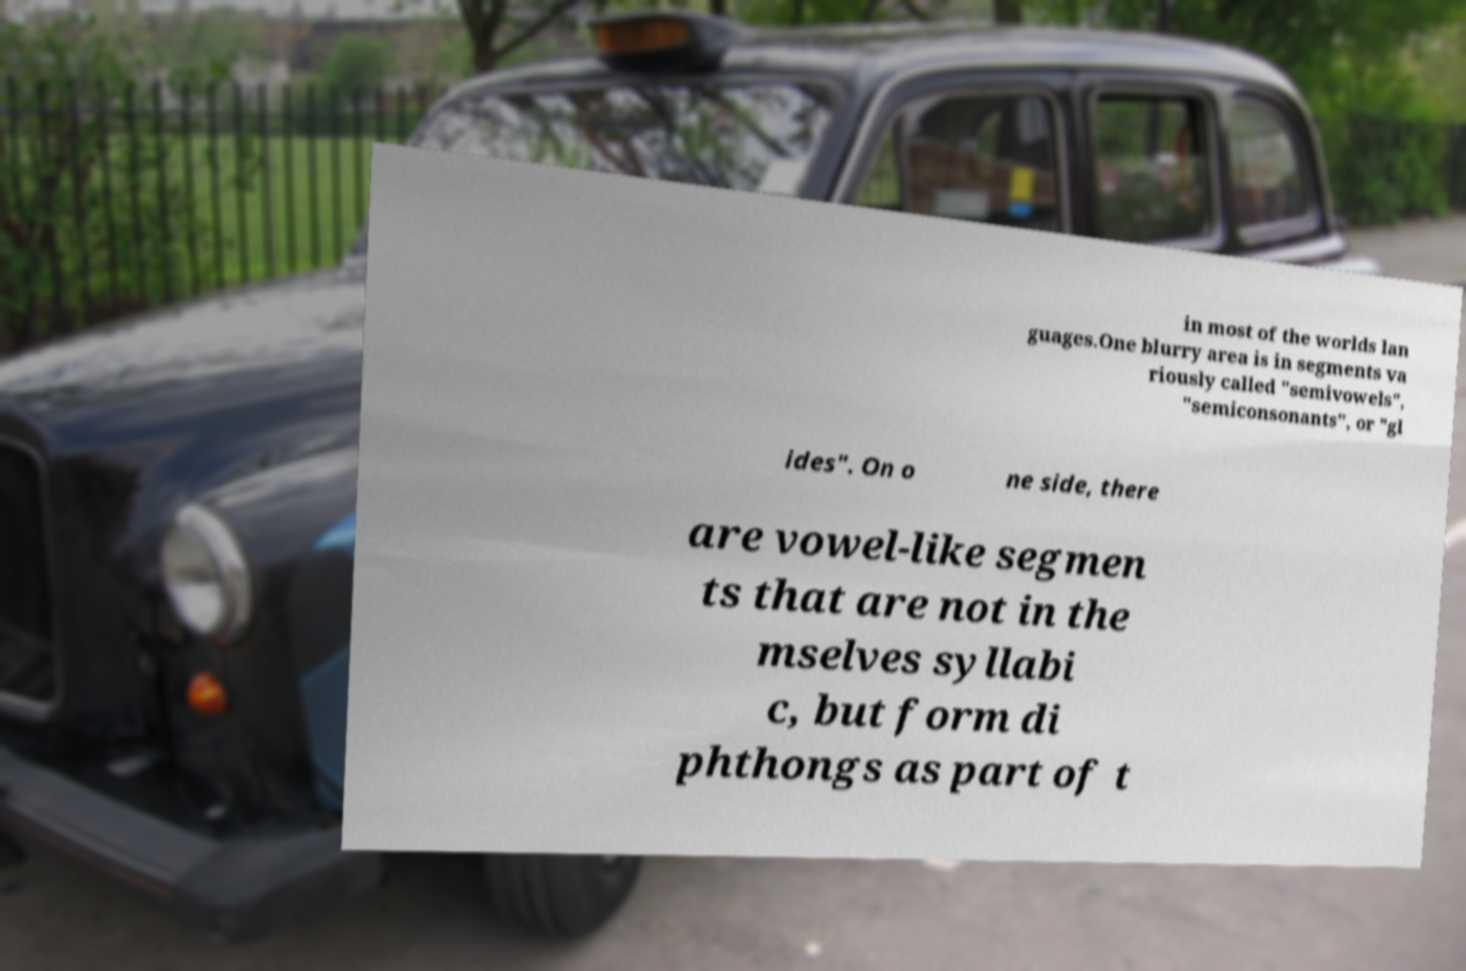Please identify and transcribe the text found in this image. in most of the worlds lan guages.One blurry area is in segments va riously called "semivowels", "semiconsonants", or "gl ides". On o ne side, there are vowel-like segmen ts that are not in the mselves syllabi c, but form di phthongs as part of t 